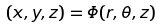Convert formula to latex. <formula><loc_0><loc_0><loc_500><loc_500>( x , y , z ) = \Phi ( r , \theta , z )</formula> 